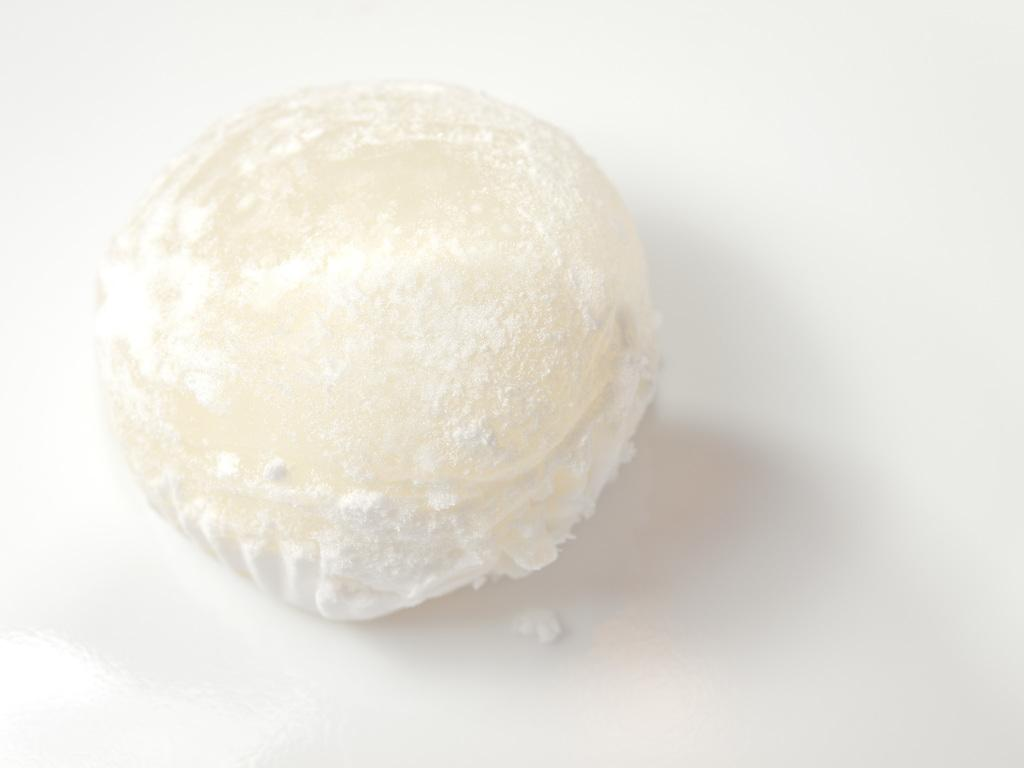What is the main subject of the image? There is a food item in the image. How many berries can be seen floating in the ocean in the image? There is no reference to berries or an ocean in the image; it only contains a food item. 